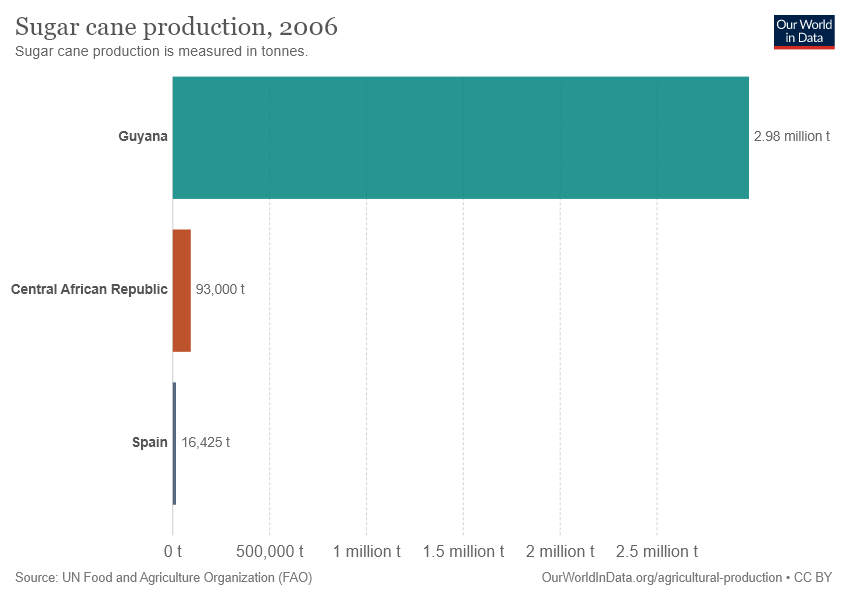List a handful of essential elements in this visual. I'm afraid I don't understand the question. Could you please clarify or provide more context so I can better assist you? Guyana is the largest producer of sugar cane in the graph. 